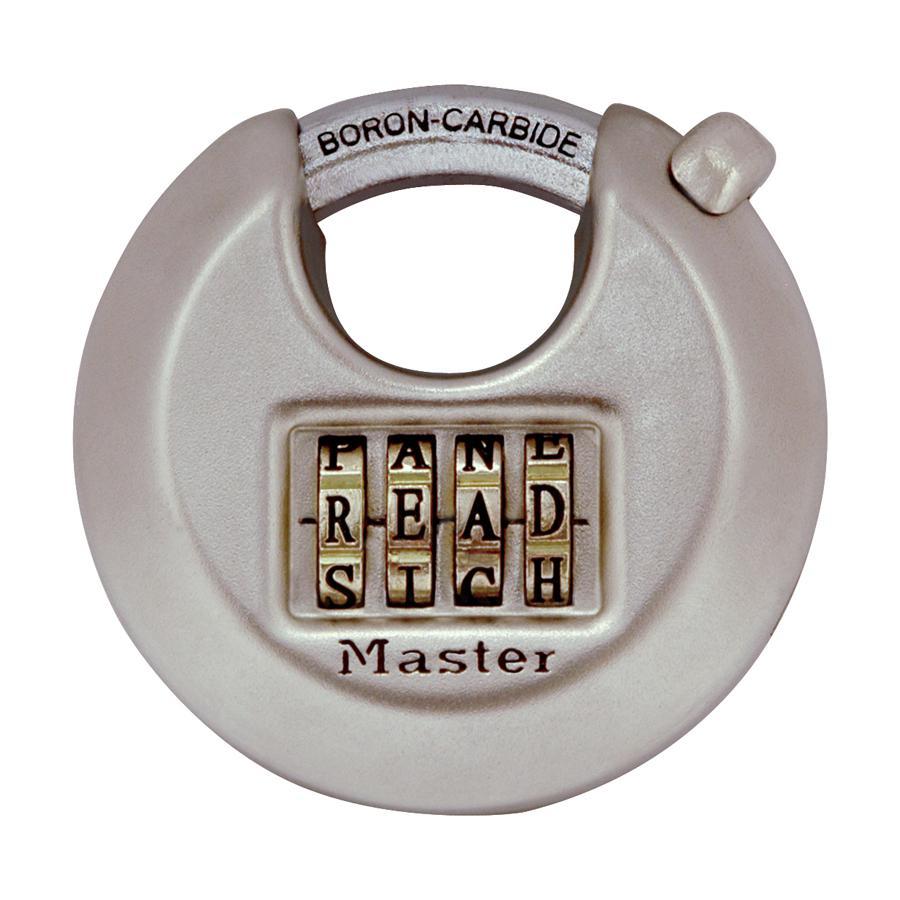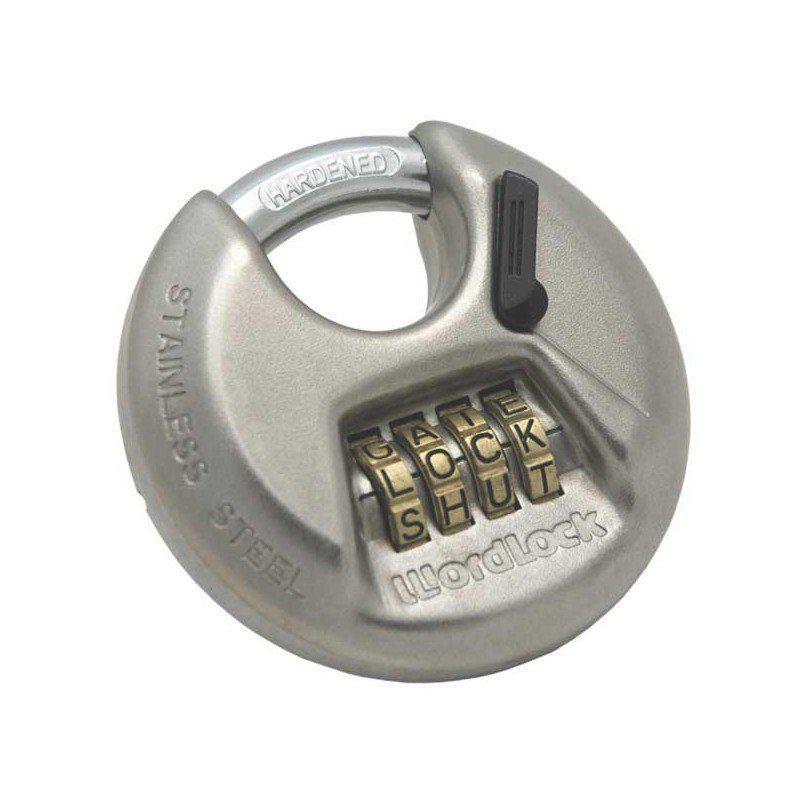The first image is the image on the left, the second image is the image on the right. For the images displayed, is the sentence "All of the locks require keys." factually correct? Answer yes or no. No. The first image is the image on the left, the second image is the image on the right. Examine the images to the left and right. Is the description "Each image shows one non-square lock, and neither lock has wheels with a combination on the front." accurate? Answer yes or no. No. 